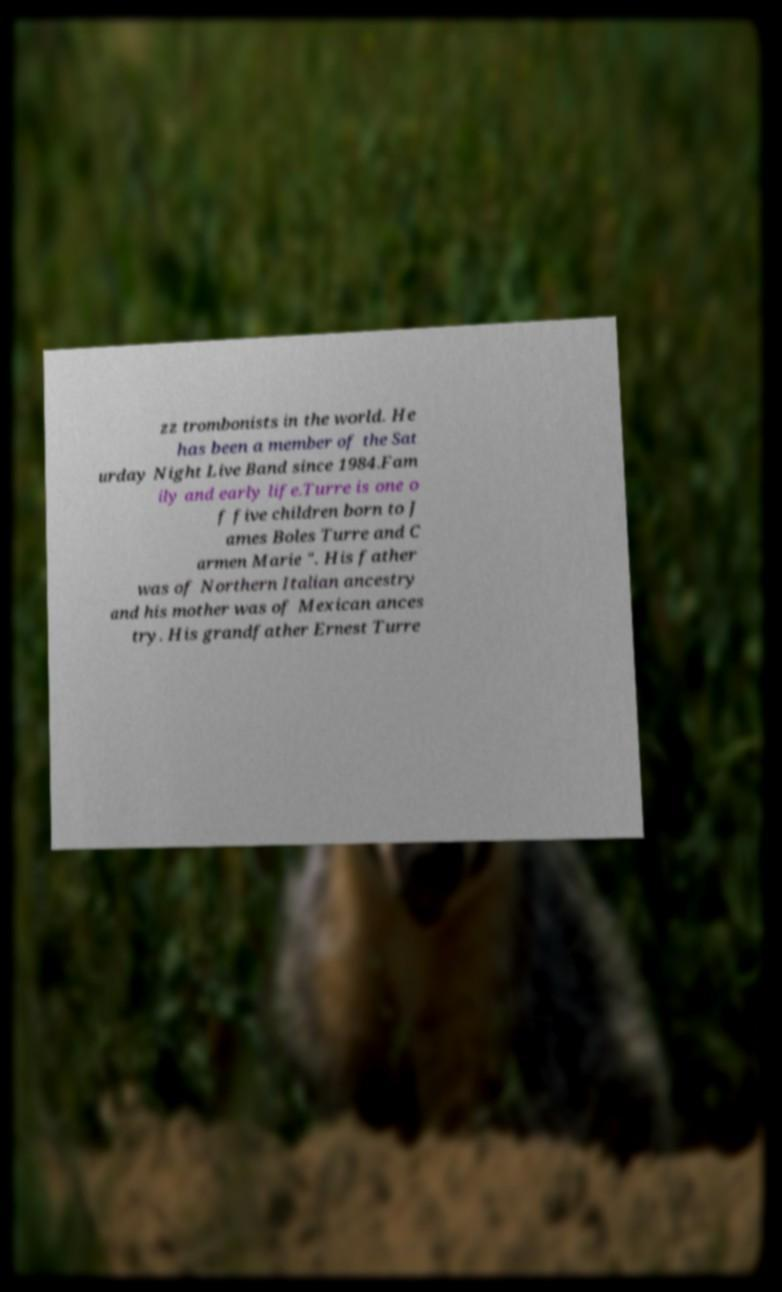Can you read and provide the text displayed in the image?This photo seems to have some interesting text. Can you extract and type it out for me? zz trombonists in the world. He has been a member of the Sat urday Night Live Band since 1984.Fam ily and early life.Turre is one o f five children born to J ames Boles Turre and C armen Marie ". His father was of Northern Italian ancestry and his mother was of Mexican ances try. His grandfather Ernest Turre 